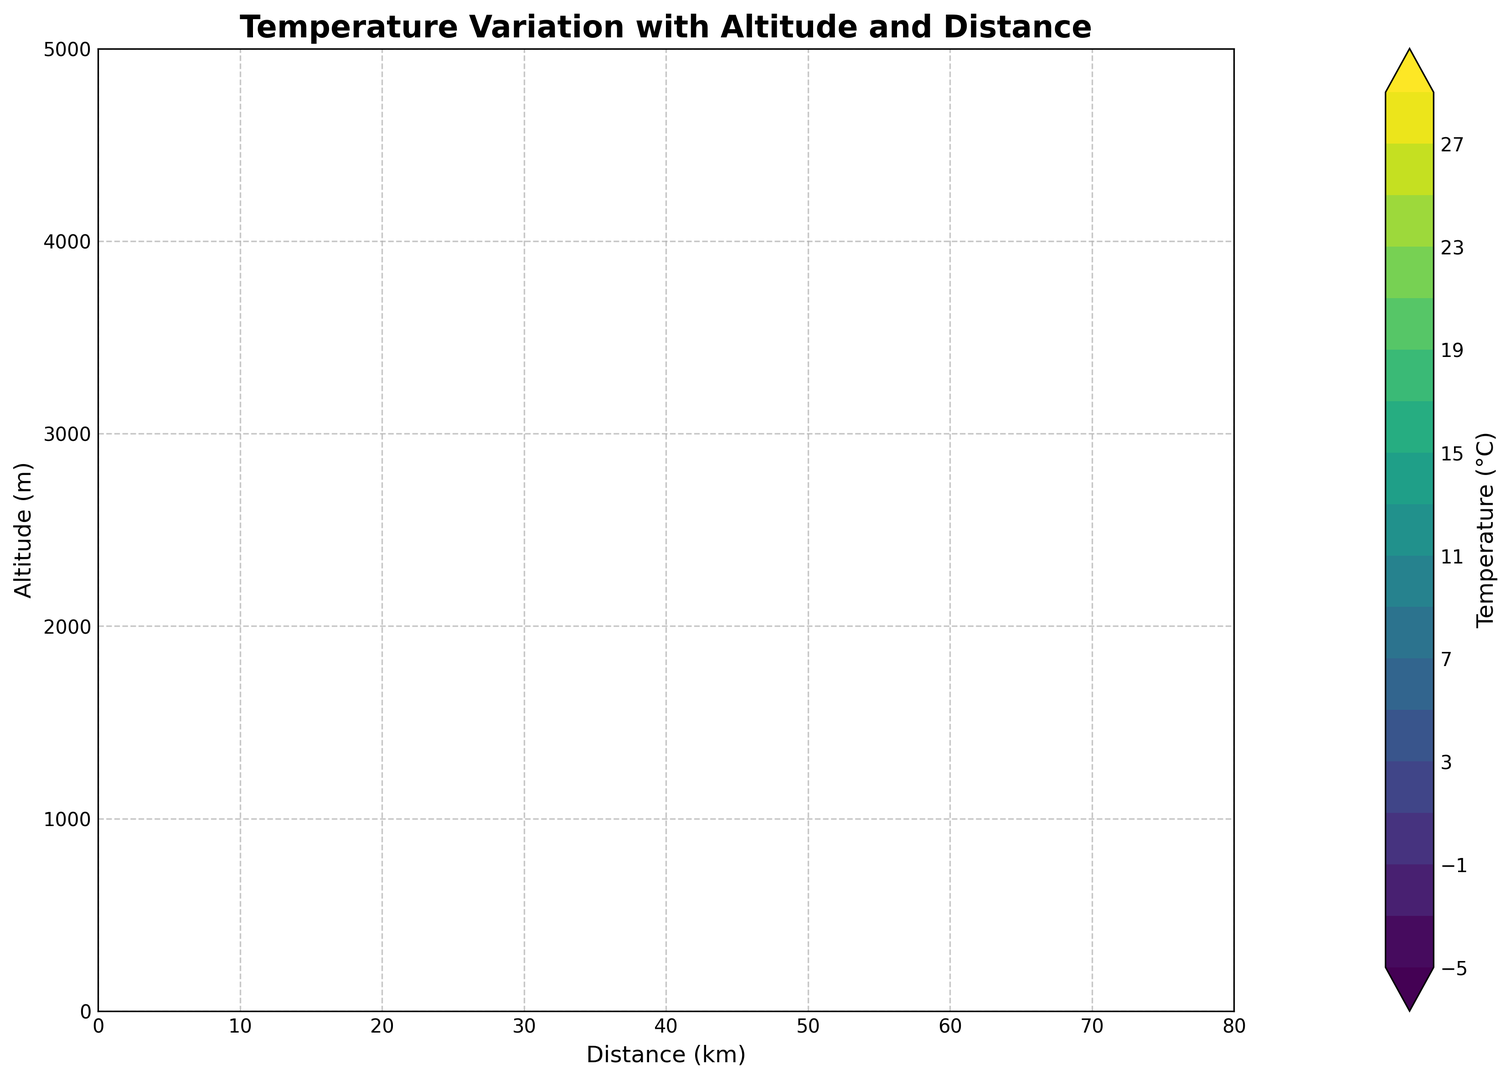How does the temperature change along the altitude from 0m to 5000m at a distance of 30 km? At a distance of 30 km, note the temperature values at each altitude. The values start at 28°C at 0m and decrease in increments of 3°C for every 500m increase in altitude, ending at -2°C at 5000m.
Answer: 28°C to -2°C At what distance does the temperature reach 0°C at an altitude of 4500m? Locate the altitude of 4500m on the y-axis and find the corresponding distance on the x-axis where the temperature contour line indicates 0°C. This occurs at 65 km.
Answer: 65 km Compare the temperature at an altitude of 3000m between distances of 10 km and 60 km. Note the temperatures at 3000m altitude for distances 10 km and 60 km. At 10 km, the temperature is 8°C, and at 60 km, it is 10°C. Comparatively, the temperature at 60 km is higher.
Answer: Higher at 60 km At what combination of altitude and distance is the highest temperature observed? Observe the color intensity on the contour plot. The warmest color represents the highest temperatures, found at the lower altitudes and nearest distances. The highest temperature of 28°C is found at 0m altitude and 30 km distance.
Answer: 0m altitude, 30 km distance What is the average temperature gradient per 1000m increase in altitude at 45 km distance? Track the temperature changes at each altitude along 45 km distance. The temperatures from 0m to 5000m are 27°C, 24°C, 21°C, 18°C, 15°C, 12°C, 9°C, 6°C, 3°C, 0°C, and -3°C respectively. The total change is (27°C - -3°C = 30°C) over 5000m. Thus, the average gradient per 1000m is 30°C/5 = 6°C.
Answer: 6°C per 1000m Which contour lines show the largest temperature range? Contour intervals that appear most spaced out or have the largest color gradient range indicate the largest temperature range. The contour lines from 0m to 5000m at 0-20 km distances show the highest range from about 27°C to -3°C.
Answer: 0m to 5000m at 0-20 km 